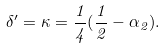<formula> <loc_0><loc_0><loc_500><loc_500>\delta ^ { \prime } = \kappa = \frac { 1 } { 4 } ( \frac { 1 } { 2 } - \alpha _ { 2 } ) .</formula> 